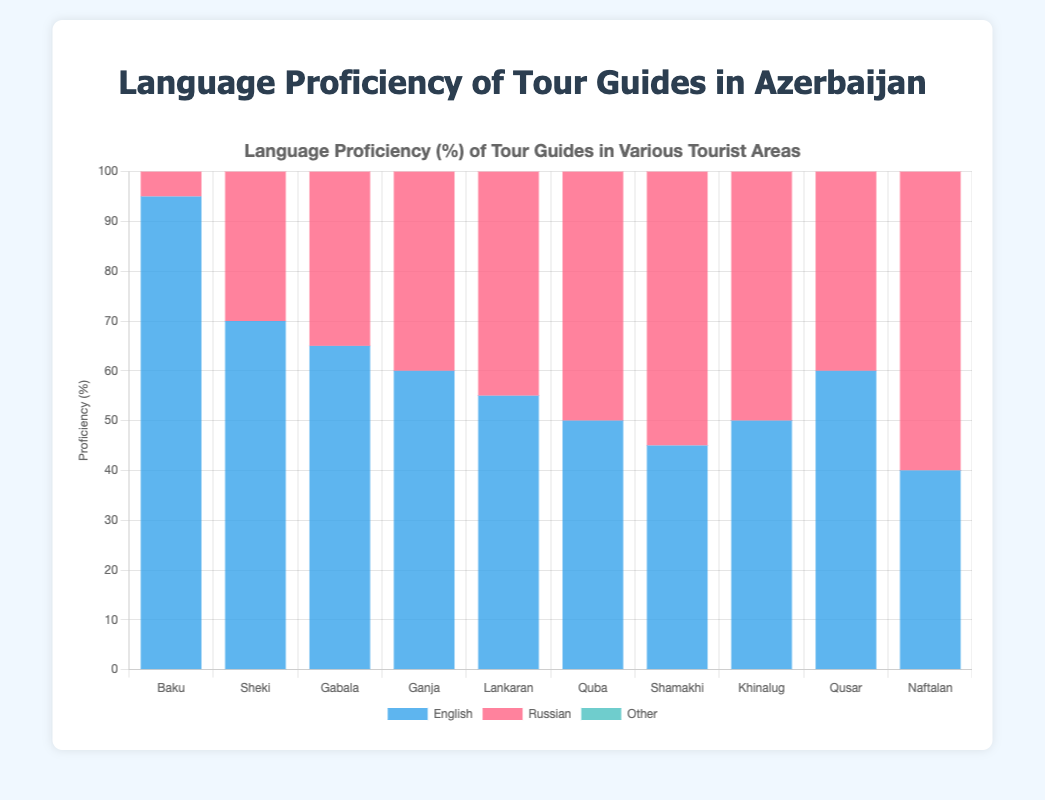Which tourist area has the highest proficiency in English? The bar for English proficiency in Baku is the tallest, indicating the highest percentage.
Answer: Baku How does the proficiency of Russian in Ganja compare to that in Lankaran? Ganja has a higher Russian proficiency than Lankaran. Ganja's bar is taller than Lankaran's for Russian proficiency (85 vs. 70).
Answer: Ganja Which tourist area has the lowest proficiency in 'Other' languages? The bar for 'Other' languages in Lankaran and Naftalan is the shortest, indicating the lowest percentage.
Answer: Lankaran and Naftalan Which tourist areas have an equal proficiency in English and what is the percentage? Both Khinalug and Quba have English proficiency bars of the same height, which is 50%.
Answer: Khinalug and Quba; 50% What is the average proficiency in English across all the tourist areas? Sum the English proficiencies: 95 (Baku) + 70 (Sheki) + 65 (Gabala) + 60 (Ganja) + 55 (Lankaran) + 50 (Quba) + 45 (Shamakhi) + 50 (Khinalug) + 60 (Qusar) + 40 (Naftalan) = 590; divide by 10 areas, 590/10.
Answer: 59 If you add the proficiency of 'Other' languages in Baku and Khinalug, what is the total? Add the 'Other' language proficiency values: 30 (Baku) + 25 (Khinalug) = 55.
Answer: 55 What is the difference in English proficiency between Baku and Naftalan? Subtract the English proficiency values: 95 (Baku) - 40 (Naftalan) = 55.
Answer: 55 Which area has a higher overall proficiency considering all three languages: Sheki or Gabala? For Sheki, the sum is 70 (English) + 75 (Russian) + 20 (Other) = 165. For Gabala, the sum is 65 (English) + 80 (Russian) + 15 (Other) = 160. Sheki’s total is higher.
Answer: Sheki What is the total proficiency in Russian across all tourist areas? Sum the Russian proficiencies: 90 (Baku) + 75 (Sheki) + 80 (Gabala) + 85 (Ganja) + 70 (Lankaran) + 65 (Quba) + 60 (Shamakhi) + 55 (Khinalug) + 75 (Qusar) + 70 (Naftalan) = 725.
Answer: 725 